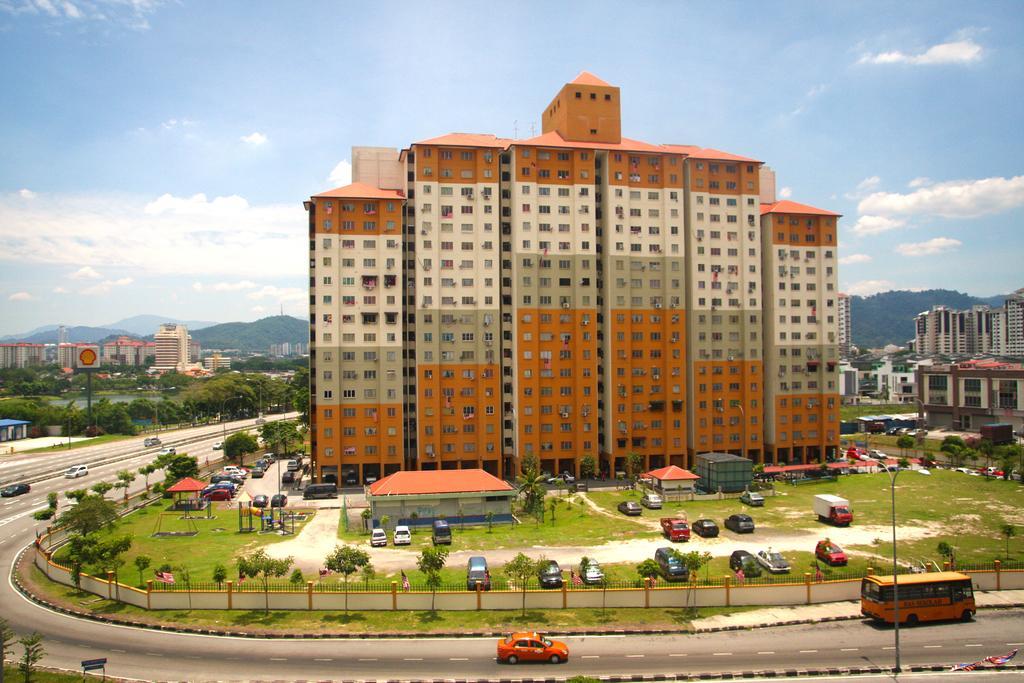Can you describe this image briefly? In this image, we can see buildings, hills, sheds, trees, boards, lights, poles, railings and we can see vehicles on the road and ground. At the top, there are clouds in the sky. 